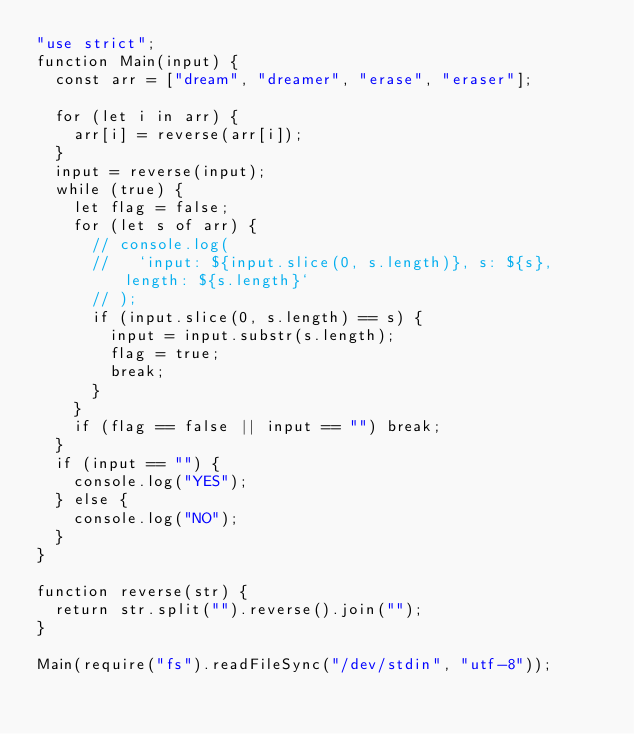Convert code to text. <code><loc_0><loc_0><loc_500><loc_500><_JavaScript_>"use strict";
function Main(input) {
  const arr = ["dream", "dreamer", "erase", "eraser"];

  for (let i in arr) {
    arr[i] = reverse(arr[i]);
  }
  input = reverse(input);
  while (true) {
    let flag = false;
    for (let s of arr) {
      // console.log(
      //   `input: ${input.slice(0, s.length)}, s: ${s}, length: ${s.length}`
      // );
      if (input.slice(0, s.length) == s) {
        input = input.substr(s.length);
        flag = true;
        break;
      }
    }
    if (flag == false || input == "") break;
  }
  if (input == "") {
    console.log("YES");
  } else {
    console.log("NO");
  }
}

function reverse(str) {
  return str.split("").reverse().join("");
}

Main(require("fs").readFileSync("/dev/stdin", "utf-8"));
</code> 